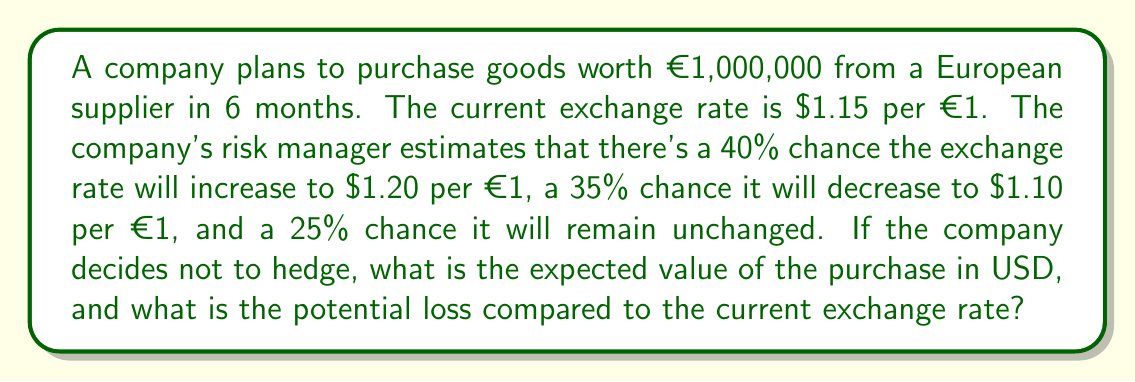Provide a solution to this math problem. 1. Calculate the current cost in USD:
   Current cost = €1,000,000 × $1.15/€ = $1,150,000

2. Calculate the cost for each potential exchange rate scenario:
   a) If rate increases to $1.20/€: €1,000,000 × $1.20/€ = $1,200,000
   b) If rate decreases to $1.10/€: €1,000,000 × $1.10/€ = $1,100,000
   c) If rate remains at $1.15/€: €1,000,000 × $1.15/€ = $1,150,000

3. Calculate the expected value using the probability of each scenario:
   E(V) = (0.40 × $1,200,000) + (0.35 × $1,100,000) + (0.25 × $1,150,000)
        = $480,000 + $385,000 + $287,500
        = $1,152,500

4. Calculate the potential loss:
   Potential loss = Expected value - Current cost
                  = $1,152,500 - $1,150,000
                  = $2,500

The expected value is $1,152,500, and the potential loss compared to the current exchange rate is $2,500.
Answer: $1,152,500; $2,500 